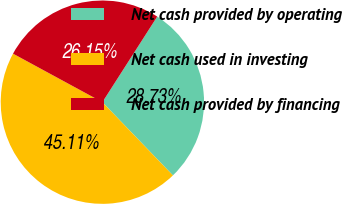<chart> <loc_0><loc_0><loc_500><loc_500><pie_chart><fcel>Net cash provided by operating<fcel>Net cash used in investing<fcel>Net cash provided by financing<nl><fcel>28.73%<fcel>45.11%<fcel>26.15%<nl></chart> 